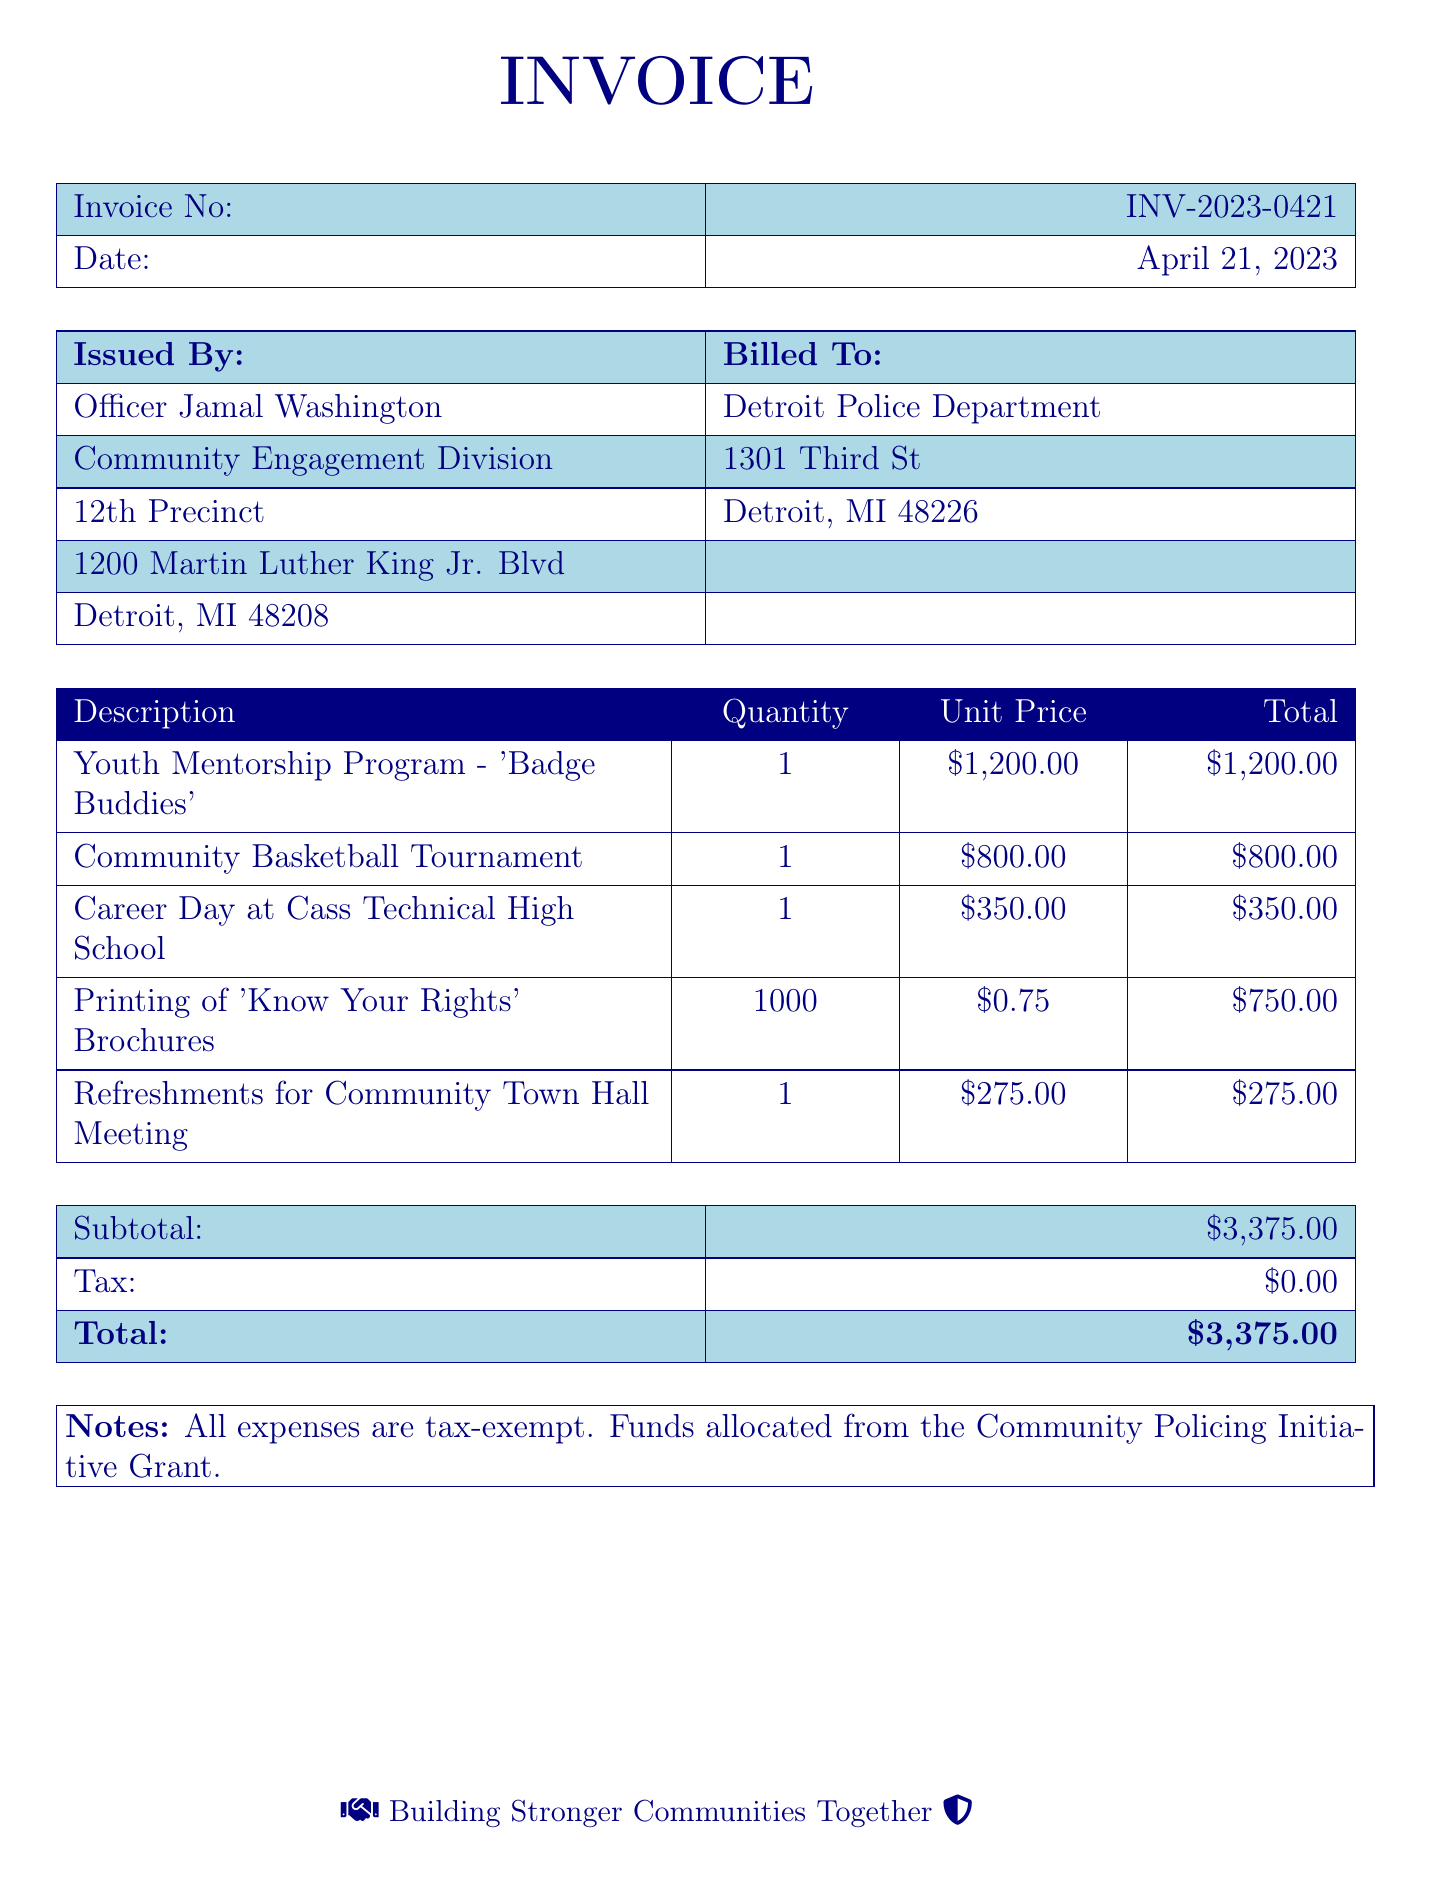What is the invoice number? The invoice number is listed at the top of the document.
Answer: INV-2023-0421 What is the subtotal amount? The subtotal is the sum of all line item totals before tax.
Answer: $3,375.00 Who is the invoice issued by? The issuer of the invoice is mentioned shortly after the invoice details.
Answer: Officer Jamal Washington What is the total amount billed? The total billed is explicitly stated at the bottom of the invoice.
Answer: $3,375.00 What activity is associated with 'Badge Buddies'? This program is explicitly mentioned as a mentorship activity in the document.
Answer: Youth Mentorship Program How many 'Know Your Rights' brochures were printed? The quantity of brochures is specified in the invoice table.
Answer: 1000 What was the tax amount for the invoice? The tax amount is explicitly noted in the invoice summary section.
Answer: $0.00 What fund is mentioned as the source for these expenses? The document specifies what funding source was used to cover these expenses.
Answer: Community Policing Initiative Grant What date was the invoice issued? The date the invoice was issued is stated in the same section as the invoice number.
Answer: April 21, 2023 